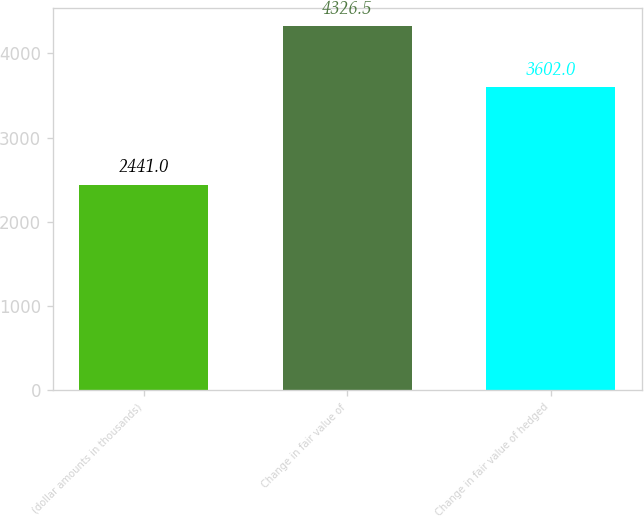Convert chart. <chart><loc_0><loc_0><loc_500><loc_500><bar_chart><fcel>(dollar amounts in thousands)<fcel>Change in fair value of<fcel>Change in fair value of hedged<nl><fcel>2441<fcel>4326.5<fcel>3602<nl></chart> 